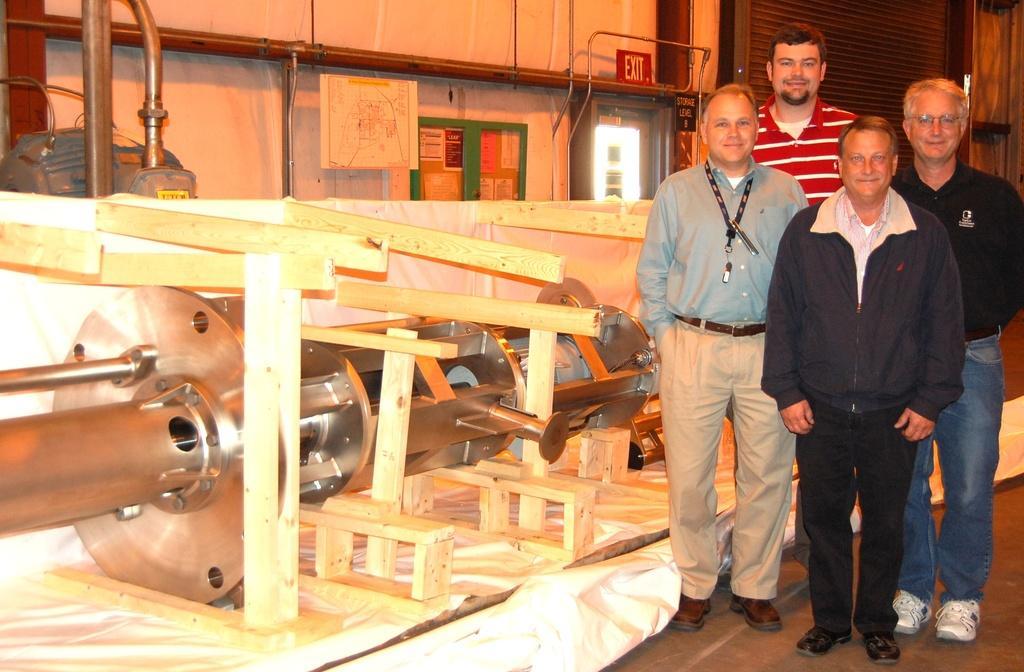Can you describe this image briefly? In the image we can see there are four men standing and beside them there are mechanical machines. 